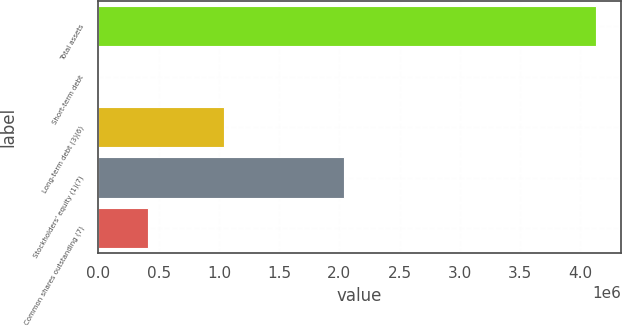<chart> <loc_0><loc_0><loc_500><loc_500><bar_chart><fcel>Total assets<fcel>Short-term debt<fcel>Long-term debt (3)(6)<fcel>Stockholders' equity (1)(7)<fcel>Common shares outstanding (7)<nl><fcel>4.12758e+06<fcel>1075<fcel>1.04539e+06<fcel>2.0421e+06<fcel>413725<nl></chart> 